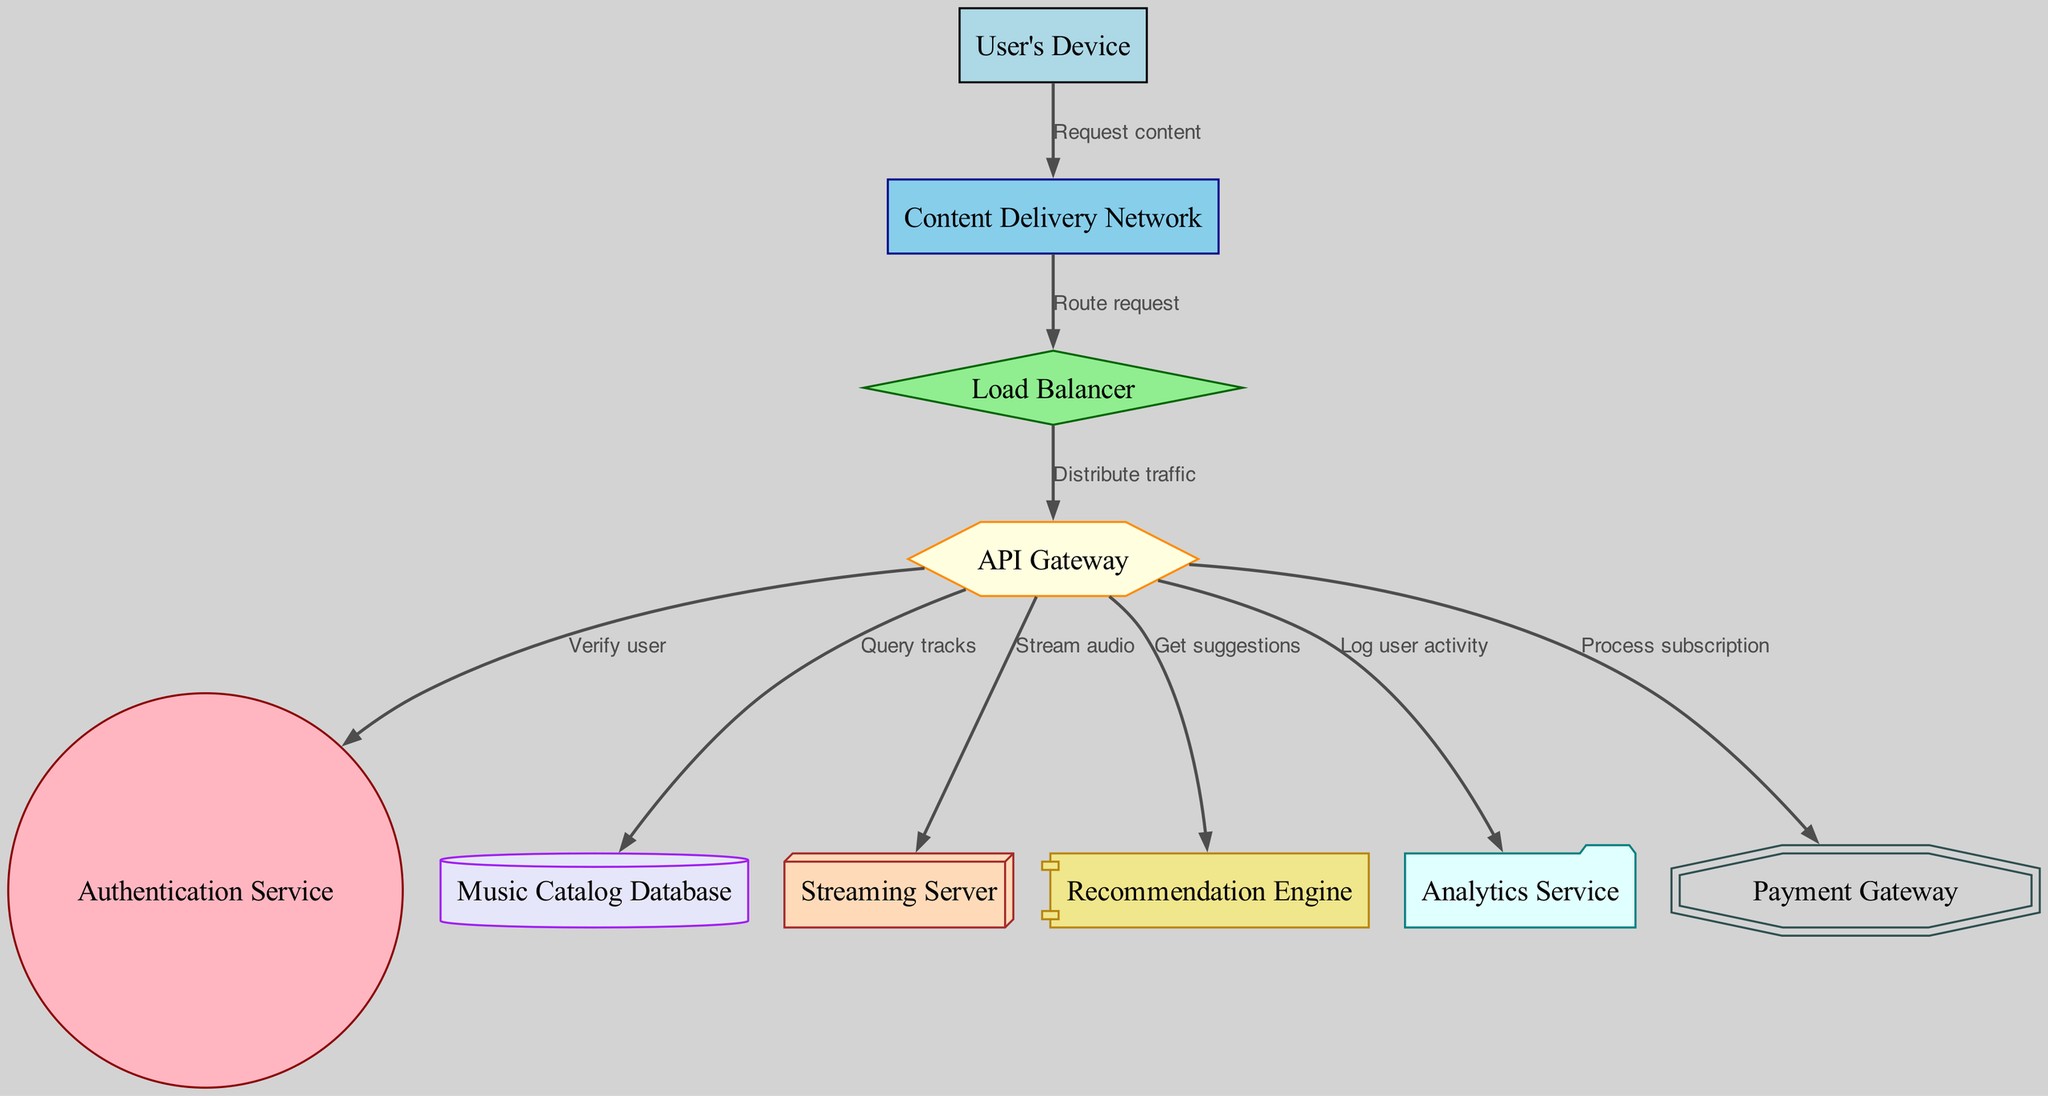What is the starting point for user requests in the diagram? The starting point for user requests is the "User's Device". This is the initial node where users interact with the system to request content.
Answer: User's Device How many nodes are present in the diagram? The diagram contains ten nodes, each representing a different component of the backend infrastructure for the digital music streaming service.
Answer: Ten Which service validates the user's identity? The "Authentication Service" is responsible for verifying the user's identity after their request passes through the "API Gateway".
Answer: Authentication Service What direction does the edge from the "Load Balancer" to the "API Gateway" point to? The edge from the "Load Balancer" points to the "API Gateway". This indicates that the load balancer distributes traffic to the API gateway.
Answer: API Gateway What is the relationship between the "API Gateway" and the "Analytics Service"? The "API Gateway" logs user activity by connecting to the "Analytics Service", which tracks and analyzes that activity.
Answer: Log user activity What are the two services that the "API Gateway" interfaces with to enhance user experience? The "API Gateway" connects with the "Recommendation Engine" to provide suggestions and the "Music Catalog Database" to query tracks, both of which enhance user experience.
Answer: Recommendation Engine and Music Catalog Database Which service is responsible for streaming audio content? The "Streaming Server" is specifically designated for the task of streaming audio content to the user's device.
Answer: Streaming Server What occurs after a user request is sent to the "Content Delivery Network"? After the user request is sent to the "Content Delivery Network", it is routed to the "Load Balancer" which then distributes the request to the appropriate services in the backend.
Answer: Route request Which components are involved in processing user subscriptions? The "Payment Gateway" is the component that handles the processing of user subscriptions as directed by the "API Gateway".
Answer: Payment Gateway 